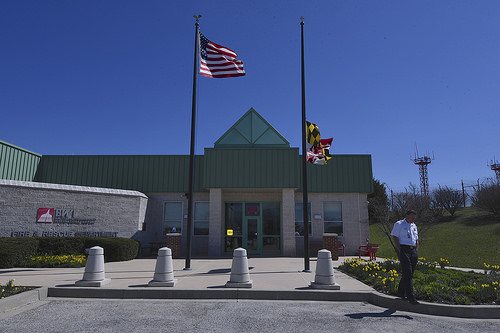<image>
Is there a flag above the man? Yes. The flag is positioned above the man in the vertical space, higher up in the scene. Is there a flag above the ground? Yes. The flag is positioned above the ground in the vertical space, higher up in the scene. 